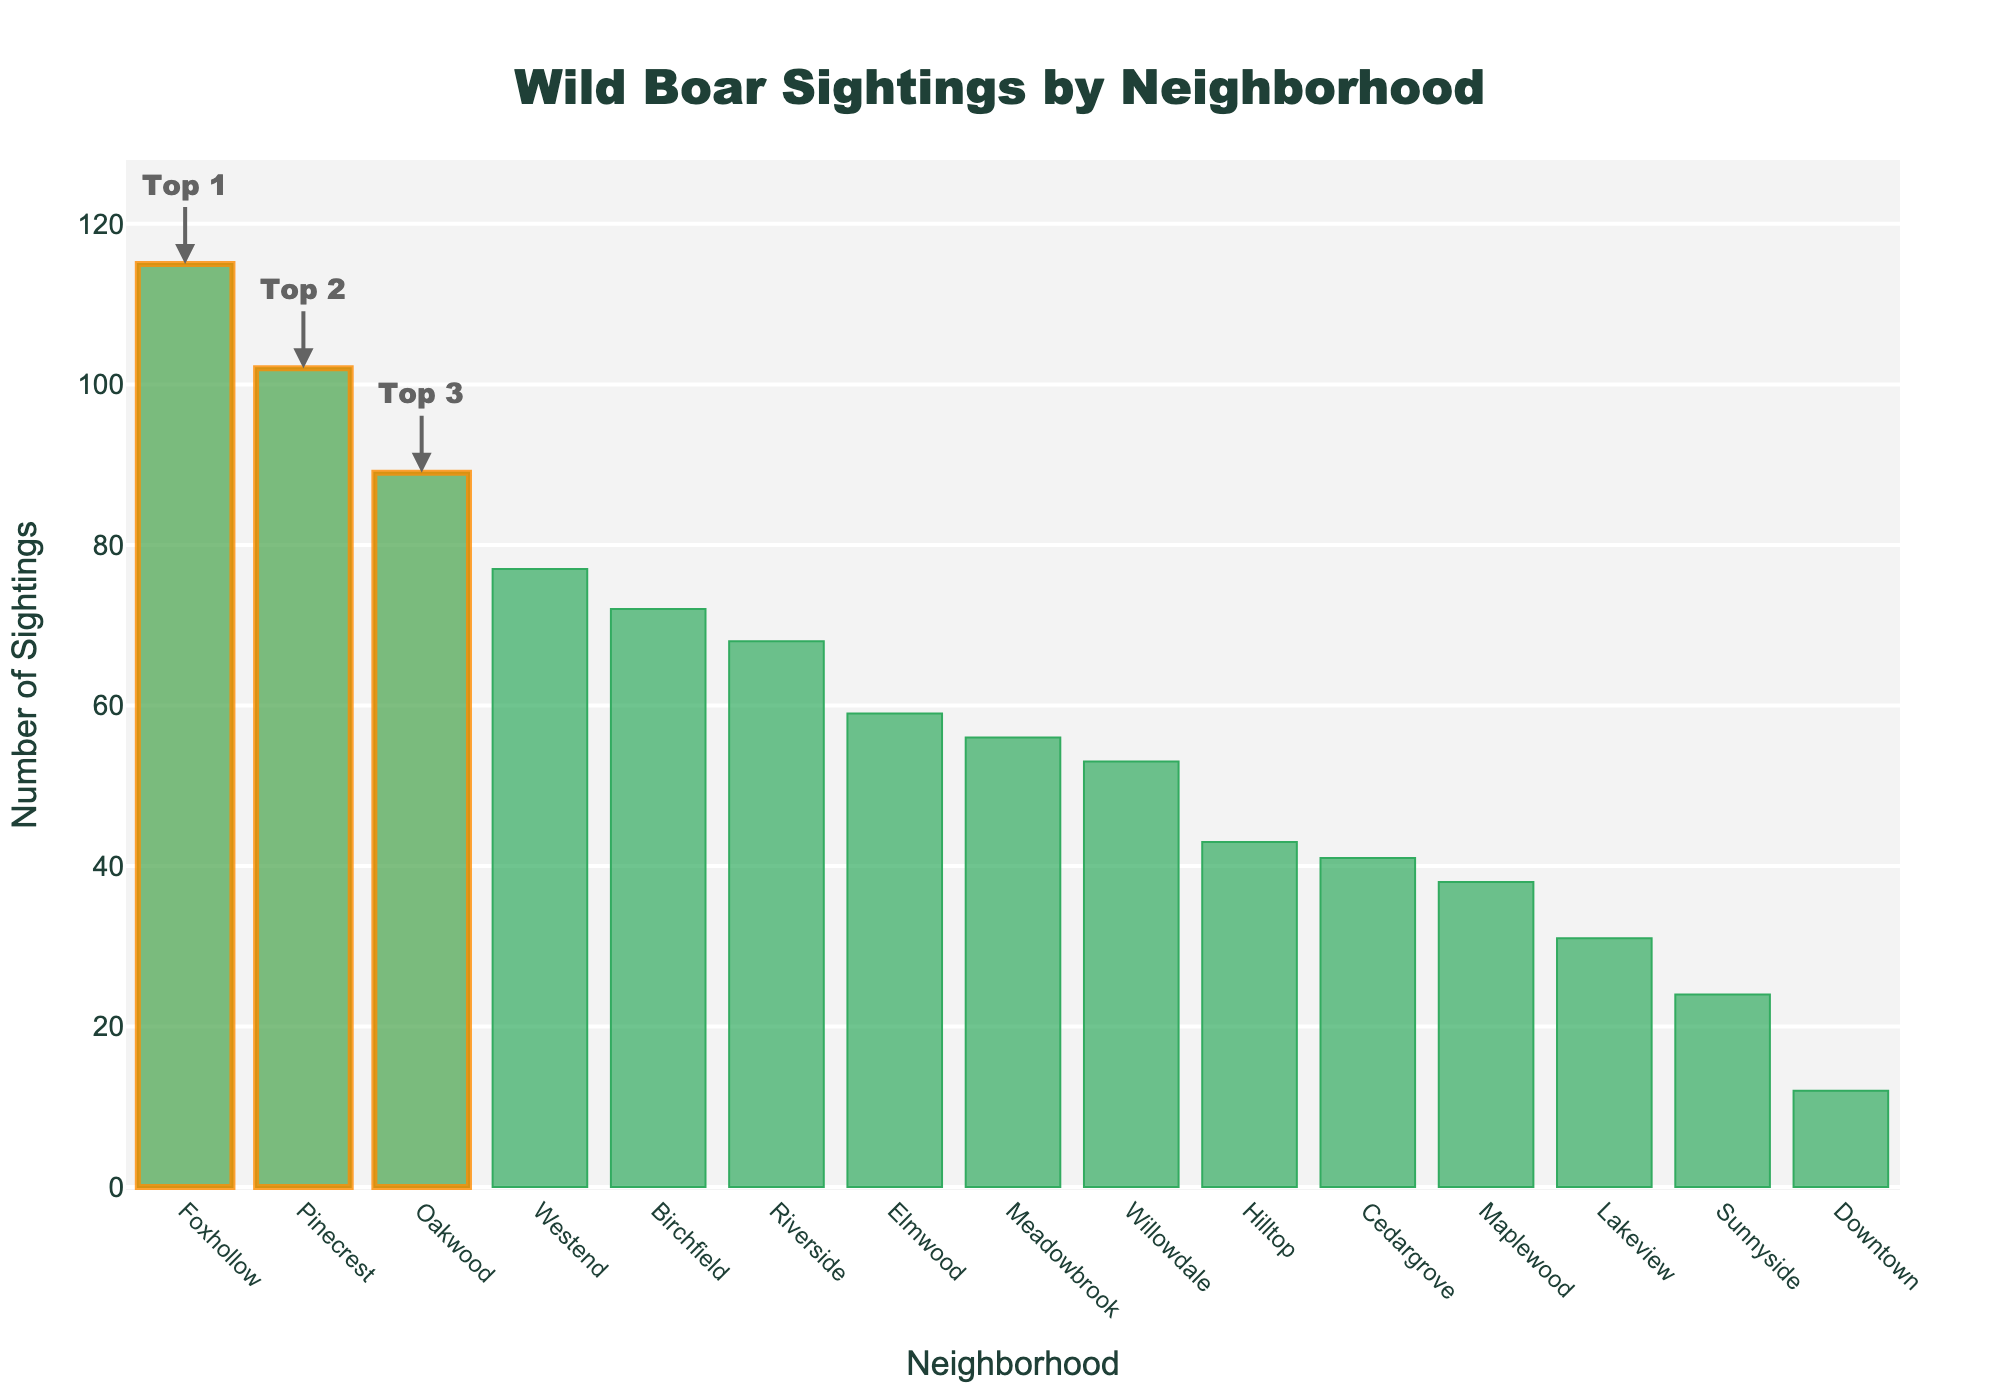What is the neighborhood with the highest number of wild boar sightings? The bar chart is sorted in descending order by the number of boar sightings, and the highest bar represents the neighborhood with the most sightings.
Answer: Foxhollow Which neighborhood has the lowest number of sightings? The last bar on the chart, which is the smallest in height, represents the neighborhood with the lowest number of sightings.
Answer: Downtown What is the sum of wild boar sightings for the top three neighborhoods? The top three neighborhoods are highlighted with rectangular shapes. Add the sightings for Foxhollow (115), Pinecrest (102), and Oakwood (89): 115 + 102 + 89 = 306.
Answer: 306 How many more boar sightings does Foxhollow have compared to Hilltop? Subtract the number of sightings in Hilltop from Foxhollow: 115 - 43.
Answer: 72 Which neighborhood has more sightings, Elmwood or Willowdale, and by how many? Compare the heights of the bars for Elmwood and Willowdale and find the difference: 59 - 53.
Answer: Elmwood, by 6 What is the average number of wild boar sightings across all neighborhoods? Sum the sightings for all neighborhoods and divide by the number of neighborhoods: (12 + 68 + 43 + 89 + 56 + 102 + 31 + 24 + 77 + 59 + 115 + 41 + 38 + 72 + 53) / 15 = 880 / 15 = 58.67.
Answer: 58.67 How many neighborhoods have more than 50 sightings? Count the bars that are above the 50 mark on the y-axis. These neighborhoods are: Riverside, Hilltop, Oakwood, Meadowbrook, Pinecrest, Westend, Elmwood, Foxhollow, Birchfield, Willowdale.
Answer: 10 What is the difference in sightings between the neighborhood with the second highest sightings and the neighborhood with the second lowest sightings? Find the number of sightings in Pinecrest (second highest) and compare it to Lakeview (second lowest): 102 - 31.
Answer: 71 Which neighborhood is closest to the overall average number of sightings? Compute the average (58.67) and find which neighborhood's number of sightings is closest to this value. It is Willowdale with 53 sightings.
Answer: Willowdale What is the total number of sightings for the neighborhoods Riverside, Meadowbrook, and Westend? Add the sightings for Riverside, Meadowbrook, and Westend: 68 + 56 + 77.
Answer: 201 